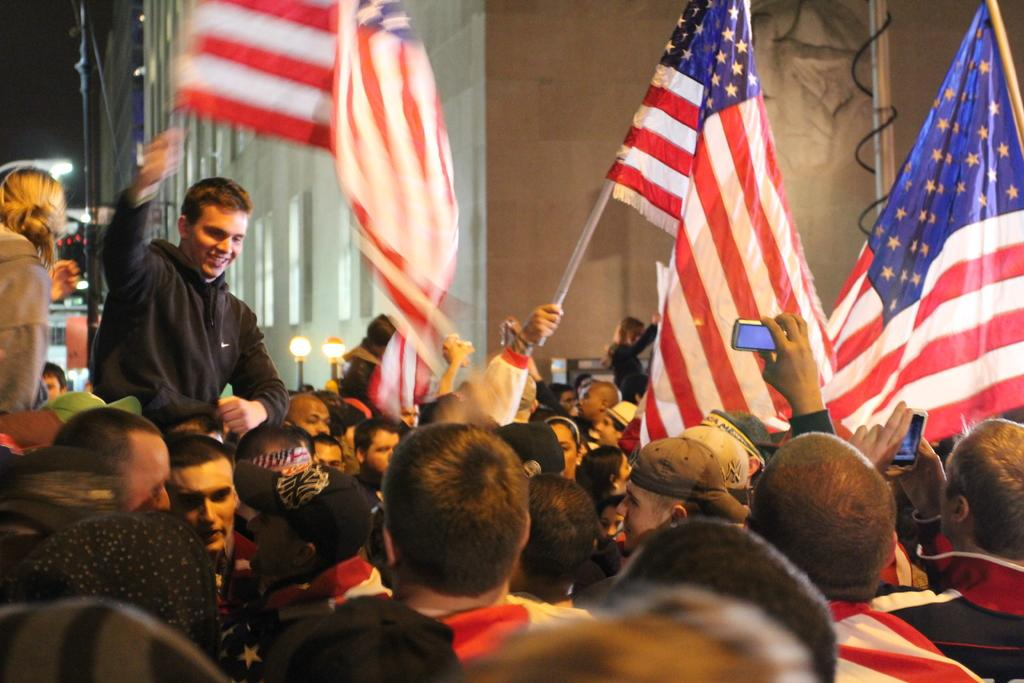Who or what can be seen in the image? There are people in the image. What structures are visible in the image? There are light poles and buildings in the image. What else can be found in the image? There are objects in the image. What are two people doing in the image? Two people are holding mobiles. What are some people doing with flags in the image? Some people are holding flags. What type of canvas is being used by the people in the image? There is no canvas present in the image; it features people, light poles, buildings, and objects. 